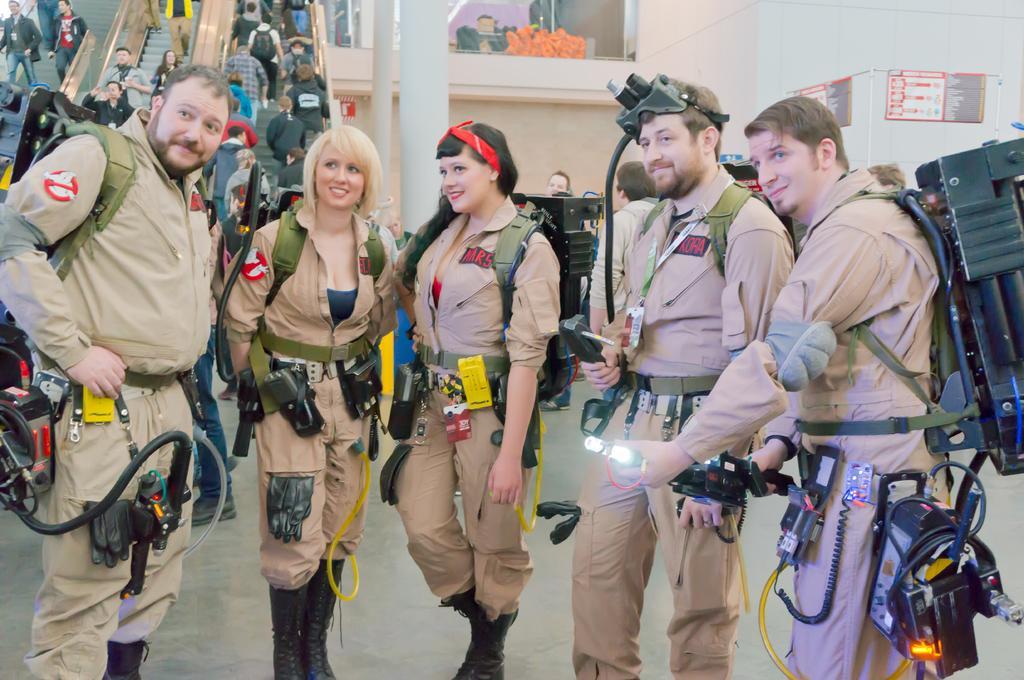In one or two sentences, can you explain what this image depicts? In the foreground of this image, there are three men and two women standing and they are wearing ghostbusters costume. In the background, there are people on the escalator and few are on the floor. We can also see pillar and few posters. 